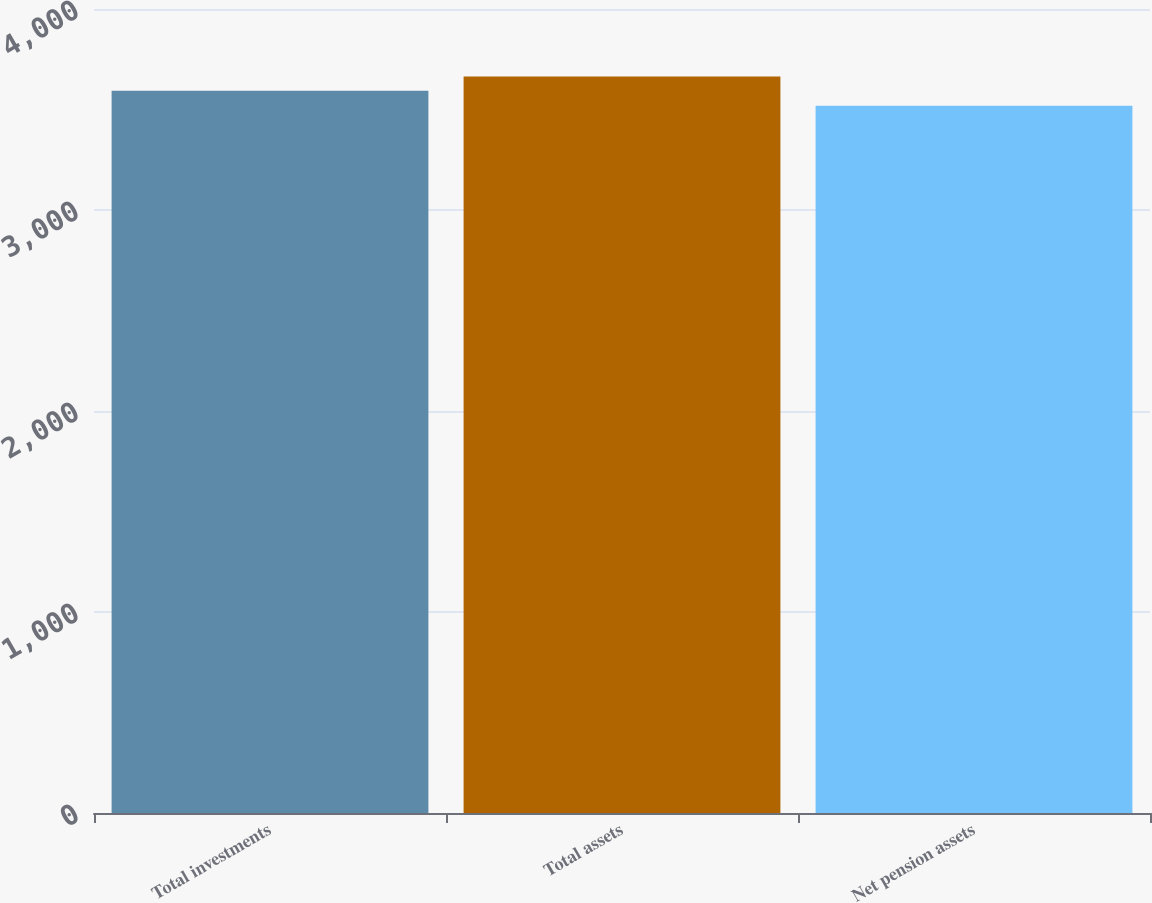Convert chart to OTSL. <chart><loc_0><loc_0><loc_500><loc_500><bar_chart><fcel>Total investments<fcel>Total assets<fcel>Net pension assets<nl><fcel>3593<fcel>3664<fcel>3519<nl></chart> 